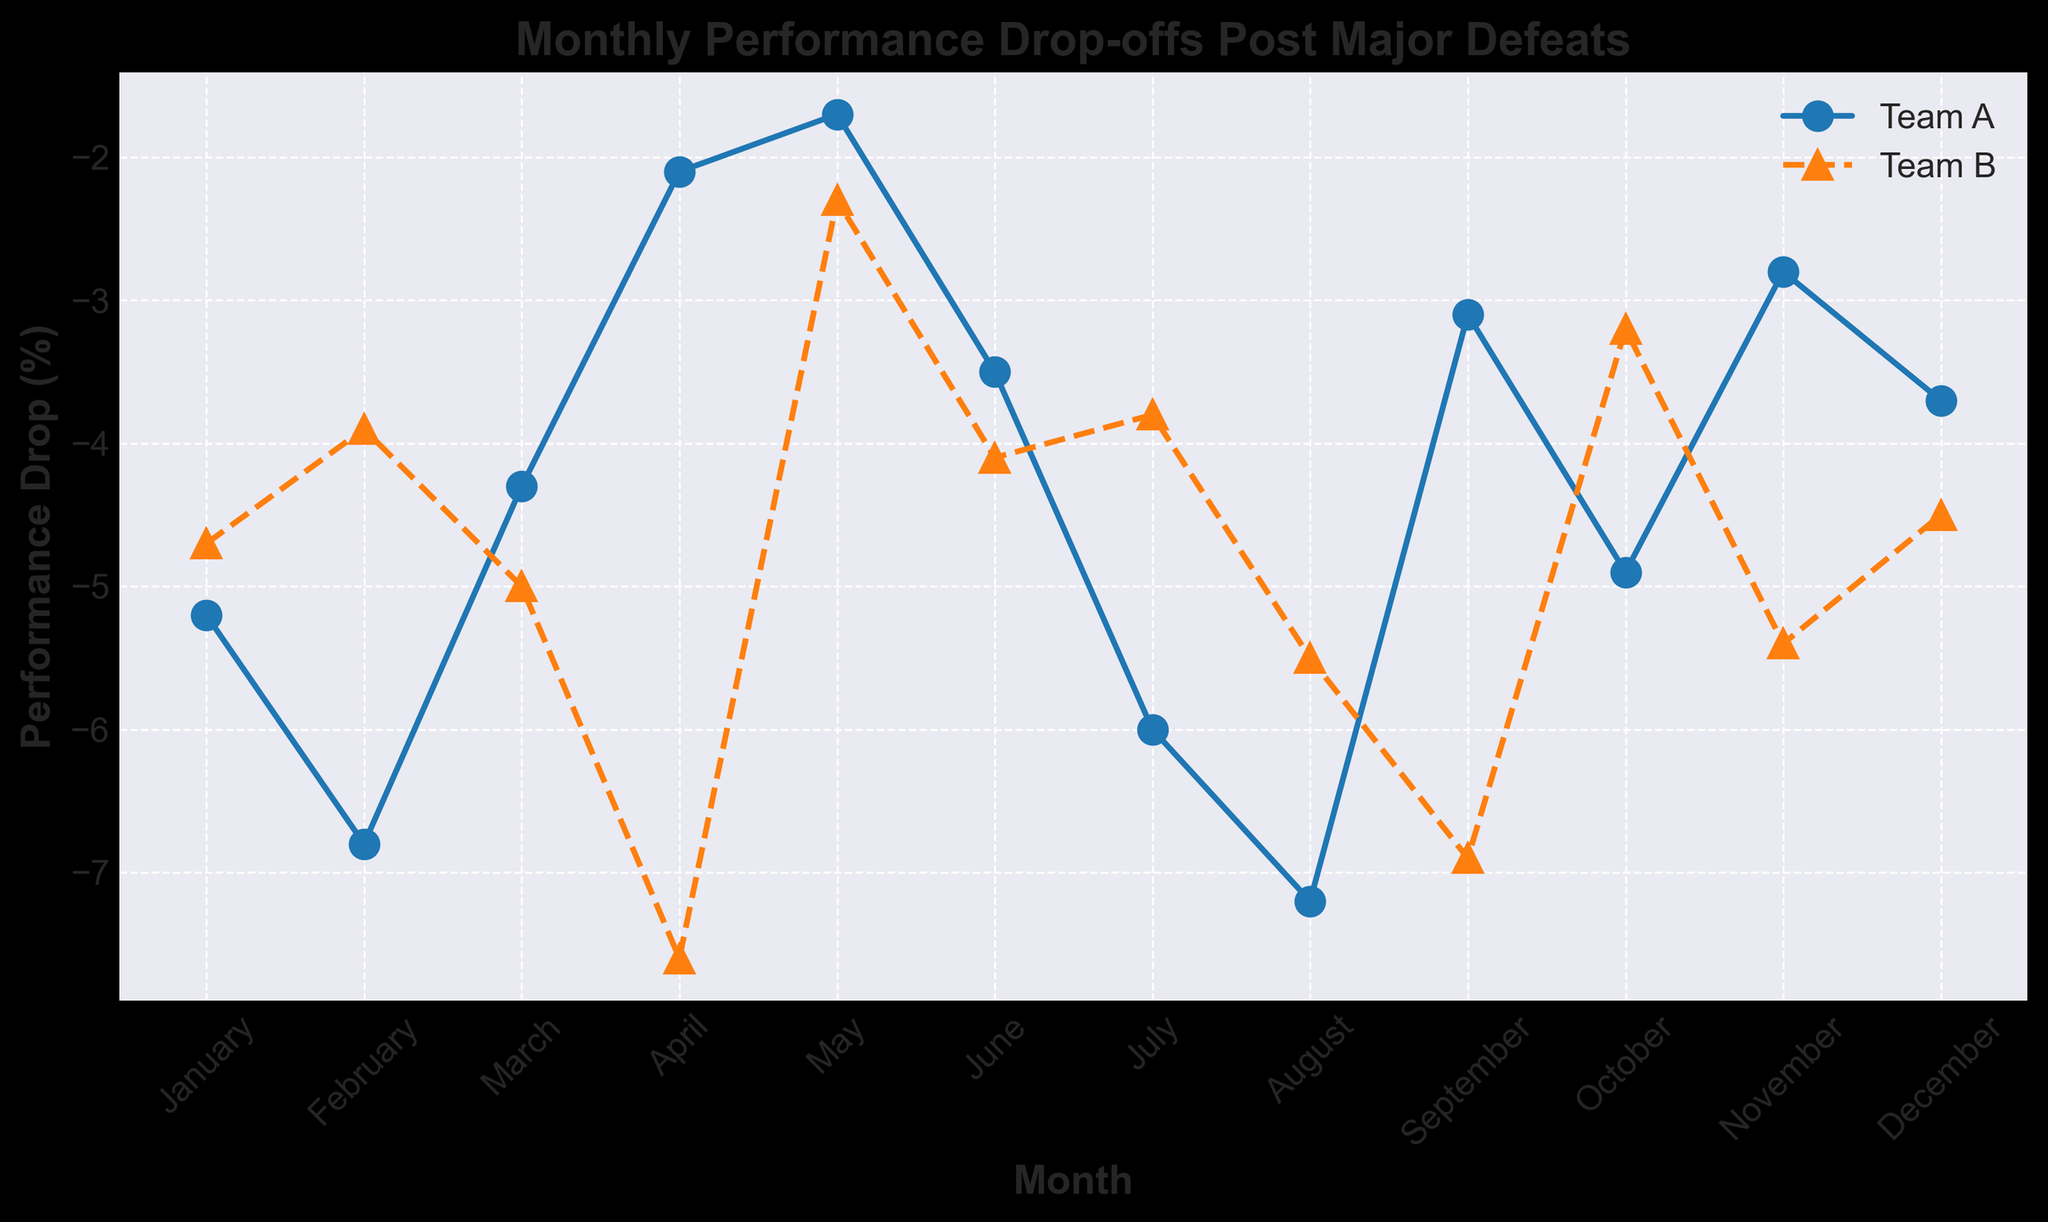Which team had the largest performance drop in February? Look at the plot and identify the February data points for both teams. Team A is at -6.8 while Team B is at -3.9. The larger negative value indicates a larger performance drop.
Answer: Team A In which month did Team B experience its highest performance drop? Look at the peaks of the Team B line. The most downward point is in April with a performance drop of -7.6.
Answer: April How much higher was Team A's performance drop in August compared to Team B in the same month? Note the values for each team in August (-7.2 for Team A and -5.5 for Team B). Compute the difference by subtracting Team B’s drop from Team A’s drop: -7.2 - (-5.5) = -1.7.
Answer: -1.7 Which team had a lower performance drop in May, and by how much? Check the May data points: Team A has -1.7, and Team B has -2.3. Team A's drop is less negative. Calculate the difference: -1.7 - (-2.3) = 0.6.
Answer: Team A by 0.6 Identify the two months with the smallest performance drop for Team A. Locate the least negative points for Team A: April (-2.1) and May (-1.7).
Answer: April and May When did Team B have a lower performance drop than Team A? Compare both teams each month. Find months where Team B's drop is numerically higher (less negative) than Team A’s: February, July, October.
Answer: February, July, October What is the average performance drop for Team A over the year? Add monthly drops: -5.2 - 6.8 - 4.3 - 2.1 - 1.7 - 3.5 - 6.0 - 7.2 - 3.1 - 4.9 - 2.8 - 3.7 = -51.3. Divide by 12: -51.3 / 12 = -4.28.
Answer: -4.28 What visual cues indicate which line represents Team B? Team B's line is marked with triangles. It also uses a dashed pattern and is colored orange.
Answer: Triangles, dashed line, orange color By how much did Team B's performance drop increase between March and April? Note the March drop (-5.0) and April drop (-7.6). Calculate the difference: -7.6 - (-5.0) = -2.6.
Answer: -2.6 What is the trend in performance drop for Team A from August to October? Observe the negative values from August (-7.2), September (-3.1), and October (-4.9); performance drop first decreases from August to September then increases in October.
Answer: Decreases, then increases 